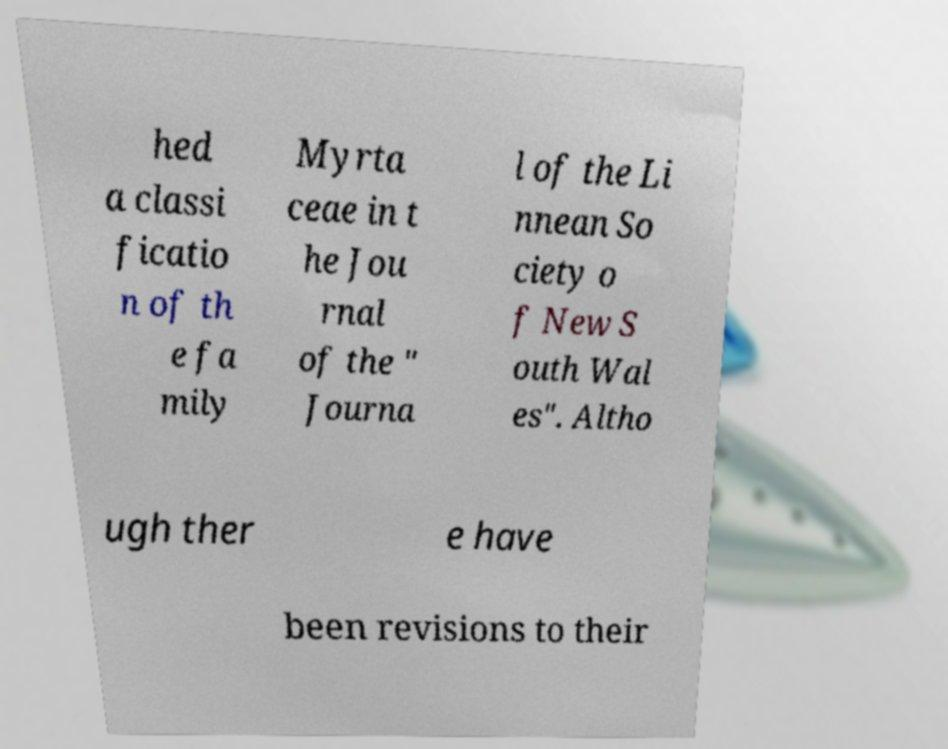I need the written content from this picture converted into text. Can you do that? hed a classi ficatio n of th e fa mily Myrta ceae in t he Jou rnal of the " Journa l of the Li nnean So ciety o f New S outh Wal es". Altho ugh ther e have been revisions to their 